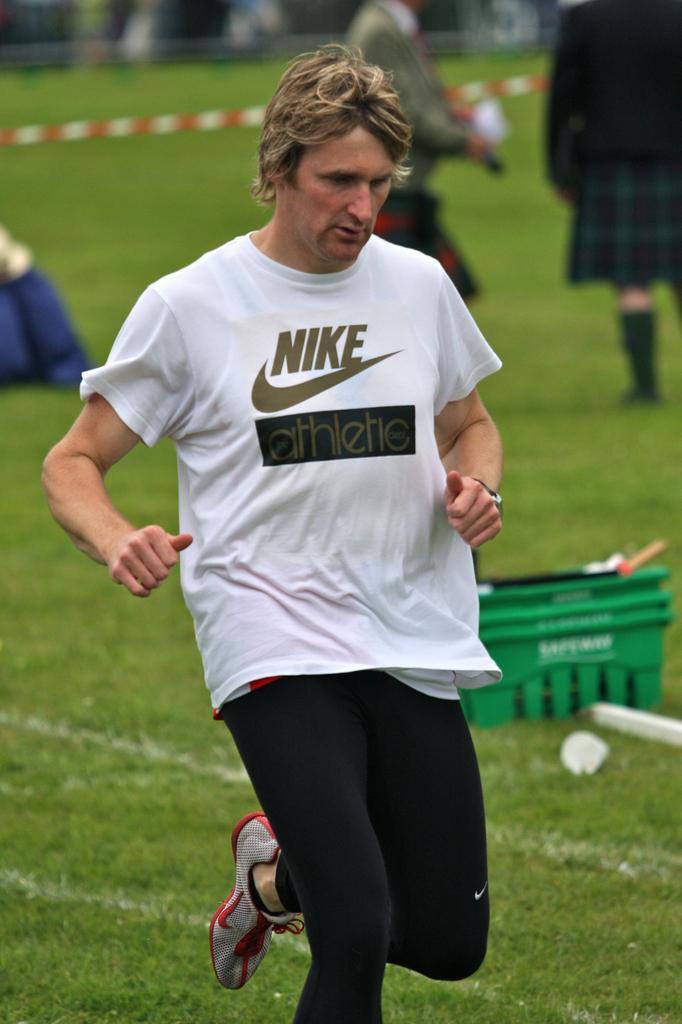Describe this image in one or two sentences. There is a man in the center of the image on the grassland and there are people, barrier tape, and a caret in the background area. 